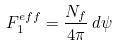Convert formula to latex. <formula><loc_0><loc_0><loc_500><loc_500>F _ { 1 } ^ { e f f } = \frac { N _ { f } } { 4 \pi } \, d \psi</formula> 